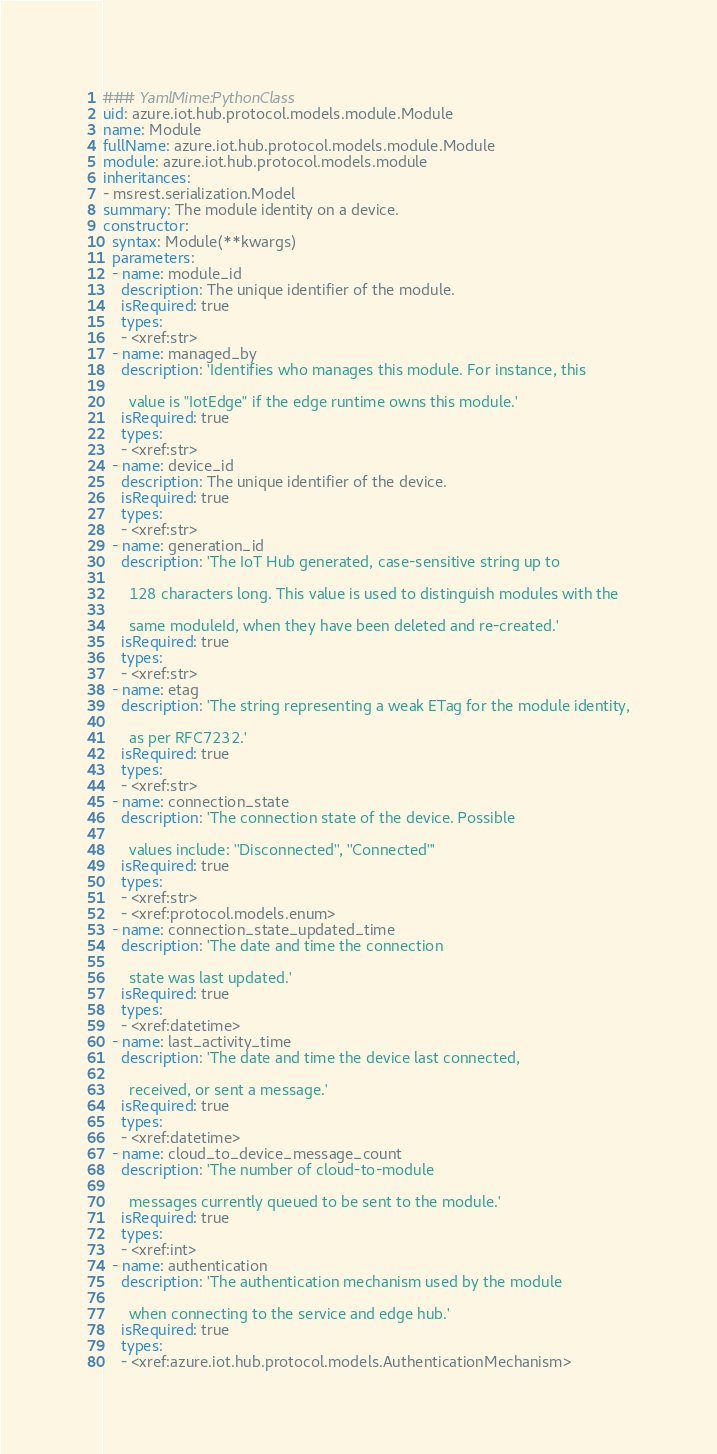<code> <loc_0><loc_0><loc_500><loc_500><_YAML_>### YamlMime:PythonClass
uid: azure.iot.hub.protocol.models.module.Module
name: Module
fullName: azure.iot.hub.protocol.models.module.Module
module: azure.iot.hub.protocol.models.module
inheritances:
- msrest.serialization.Model
summary: The module identity on a device.
constructor:
  syntax: Module(**kwargs)
  parameters:
  - name: module_id
    description: The unique identifier of the module.
    isRequired: true
    types:
    - <xref:str>
  - name: managed_by
    description: 'Identifies who manages this module. For instance, this

      value is "IotEdge" if the edge runtime owns this module.'
    isRequired: true
    types:
    - <xref:str>
  - name: device_id
    description: The unique identifier of the device.
    isRequired: true
    types:
    - <xref:str>
  - name: generation_id
    description: 'The IoT Hub generated, case-sensitive string up to

      128 characters long. This value is used to distinguish modules with the

      same moduleId, when they have been deleted and re-created.'
    isRequired: true
    types:
    - <xref:str>
  - name: etag
    description: 'The string representing a weak ETag for the module identity,

      as per RFC7232.'
    isRequired: true
    types:
    - <xref:str>
  - name: connection_state
    description: 'The connection state of the device. Possible

      values include: ''Disconnected'', ''Connected'''
    isRequired: true
    types:
    - <xref:str>
    - <xref:protocol.models.enum>
  - name: connection_state_updated_time
    description: 'The date and time the connection

      state was last updated.'
    isRequired: true
    types:
    - <xref:datetime>
  - name: last_activity_time
    description: 'The date and time the device last connected,

      received, or sent a message.'
    isRequired: true
    types:
    - <xref:datetime>
  - name: cloud_to_device_message_count
    description: 'The number of cloud-to-module

      messages currently queued to be sent to the module.'
    isRequired: true
    types:
    - <xref:int>
  - name: authentication
    description: 'The authentication mechanism used by the module

      when connecting to the service and edge hub.'
    isRequired: true
    types:
    - <xref:azure.iot.hub.protocol.models.AuthenticationMechanism>
</code> 